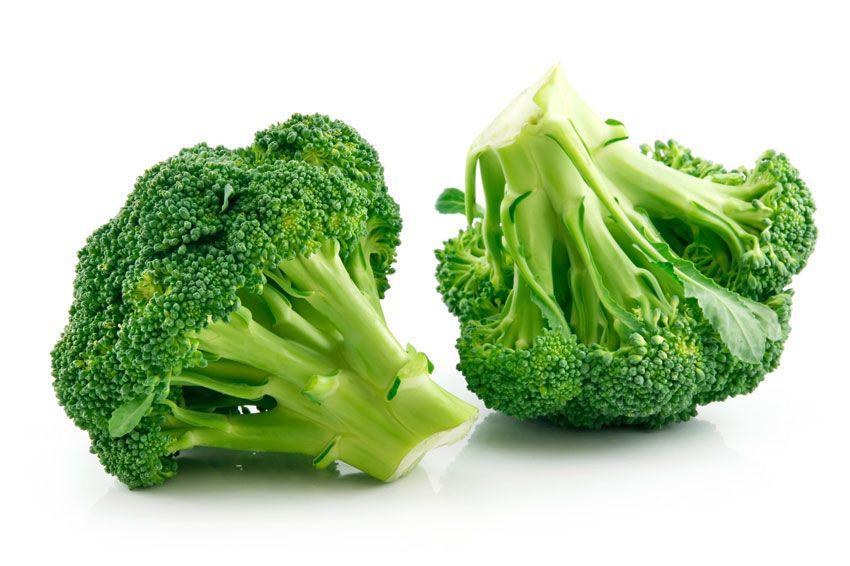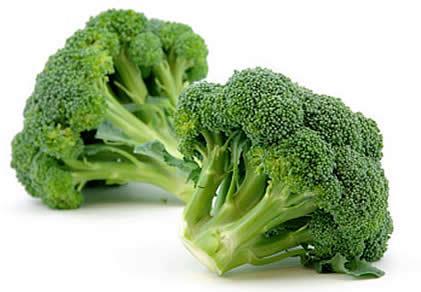The first image is the image on the left, the second image is the image on the right. Given the left and right images, does the statement "In at least one image there is a single head of green cauliflower." hold true? Answer yes or no. No. The first image is the image on the left, the second image is the image on the right. Evaluate the accuracy of this statement regarding the images: "One image shows one roundish head of a yellow-green cauliflower type vegetable, and the other image features darker green broccoli florets.". Is it true? Answer yes or no. No. 